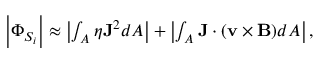<formula> <loc_0><loc_0><loc_500><loc_500>\begin{array} { r } { \left | \Phi _ { S _ { i } } \right | \approx \left | \int _ { A } \eta { J } ^ { 2 } d A \right | + \left | \int _ { A } { J } \cdot ( { v } \times { B } ) d A \right | , } \end{array}</formula> 